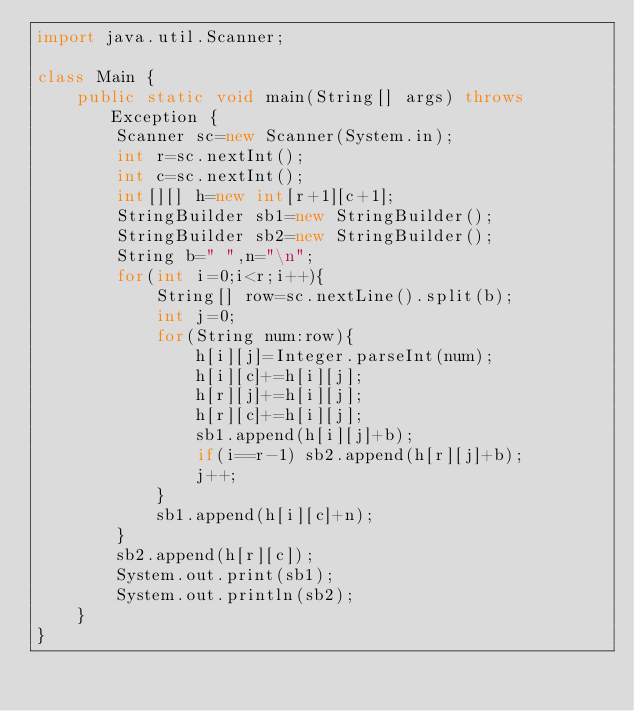<code> <loc_0><loc_0><loc_500><loc_500><_Java_>import java.util.Scanner;

class Main {
	public static void main(String[] args) throws Exception {
		Scanner sc=new Scanner(System.in);
		int r=sc.nextInt();
		int c=sc.nextInt();
        int[][] h=new int[r+1][c+1];
		StringBuilder sb1=new StringBuilder();
		StringBuilder sb2=new StringBuilder();
		String b=" ",n="\n";
        for(int i=0;i<r;i++){
        	String[] row=sc.nextLine().split(b);
        	int j=0;
        	for(String num:row){
        		h[i][j]=Integer.parseInt(num);
        		h[i][c]+=h[i][j];
        		h[r][j]+=h[i][j];
        		h[r][c]+=h[i][j];
        		sb1.append(h[i][j]+b);
        		if(i==r-1) sb2.append(h[r][j]+b);
        		j++;
        	}
        	sb1.append(h[i][c]+n);
        }
        sb2.append(h[r][c]);
        System.out.print(sb1);
        System.out.println(sb2);
	}
}</code> 